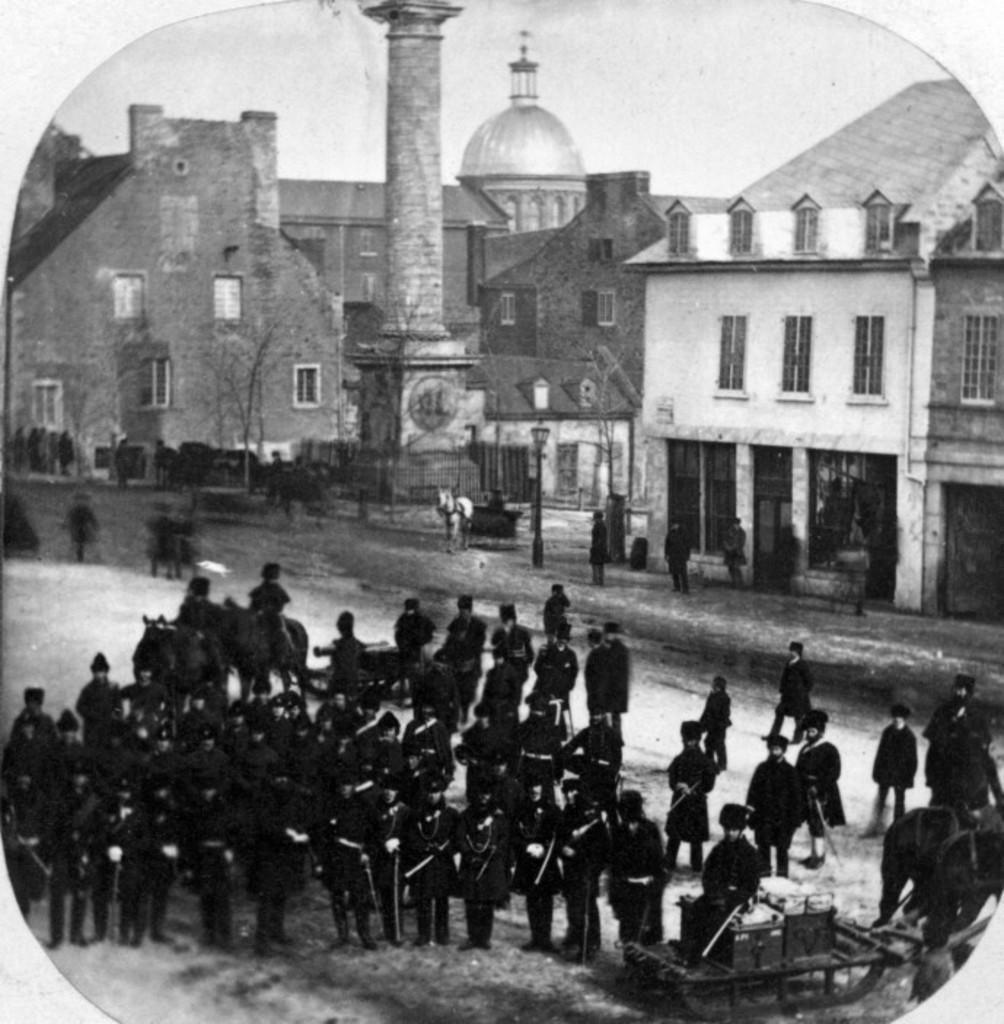Can you describe this image briefly? In this image I can see group of people standing and wearing black color dress. Back Side I can see a building,windows and light pole. I can see a horse. The image is in black and white. 